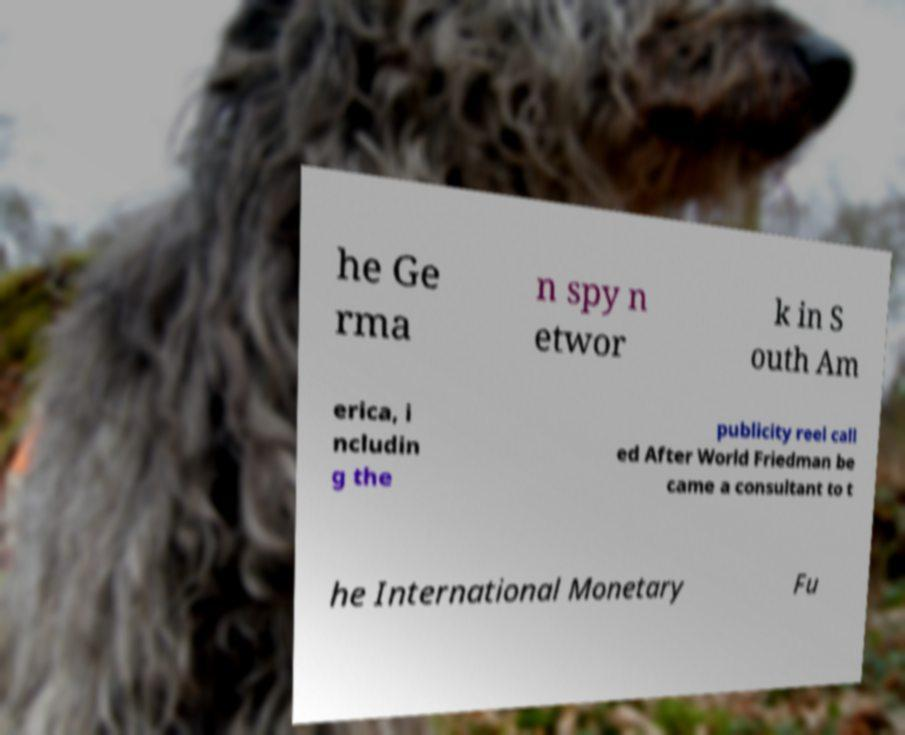What messages or text are displayed in this image? I need them in a readable, typed format. he Ge rma n spy n etwor k in S outh Am erica, i ncludin g the publicity reel call ed After World Friedman be came a consultant to t he International Monetary Fu 